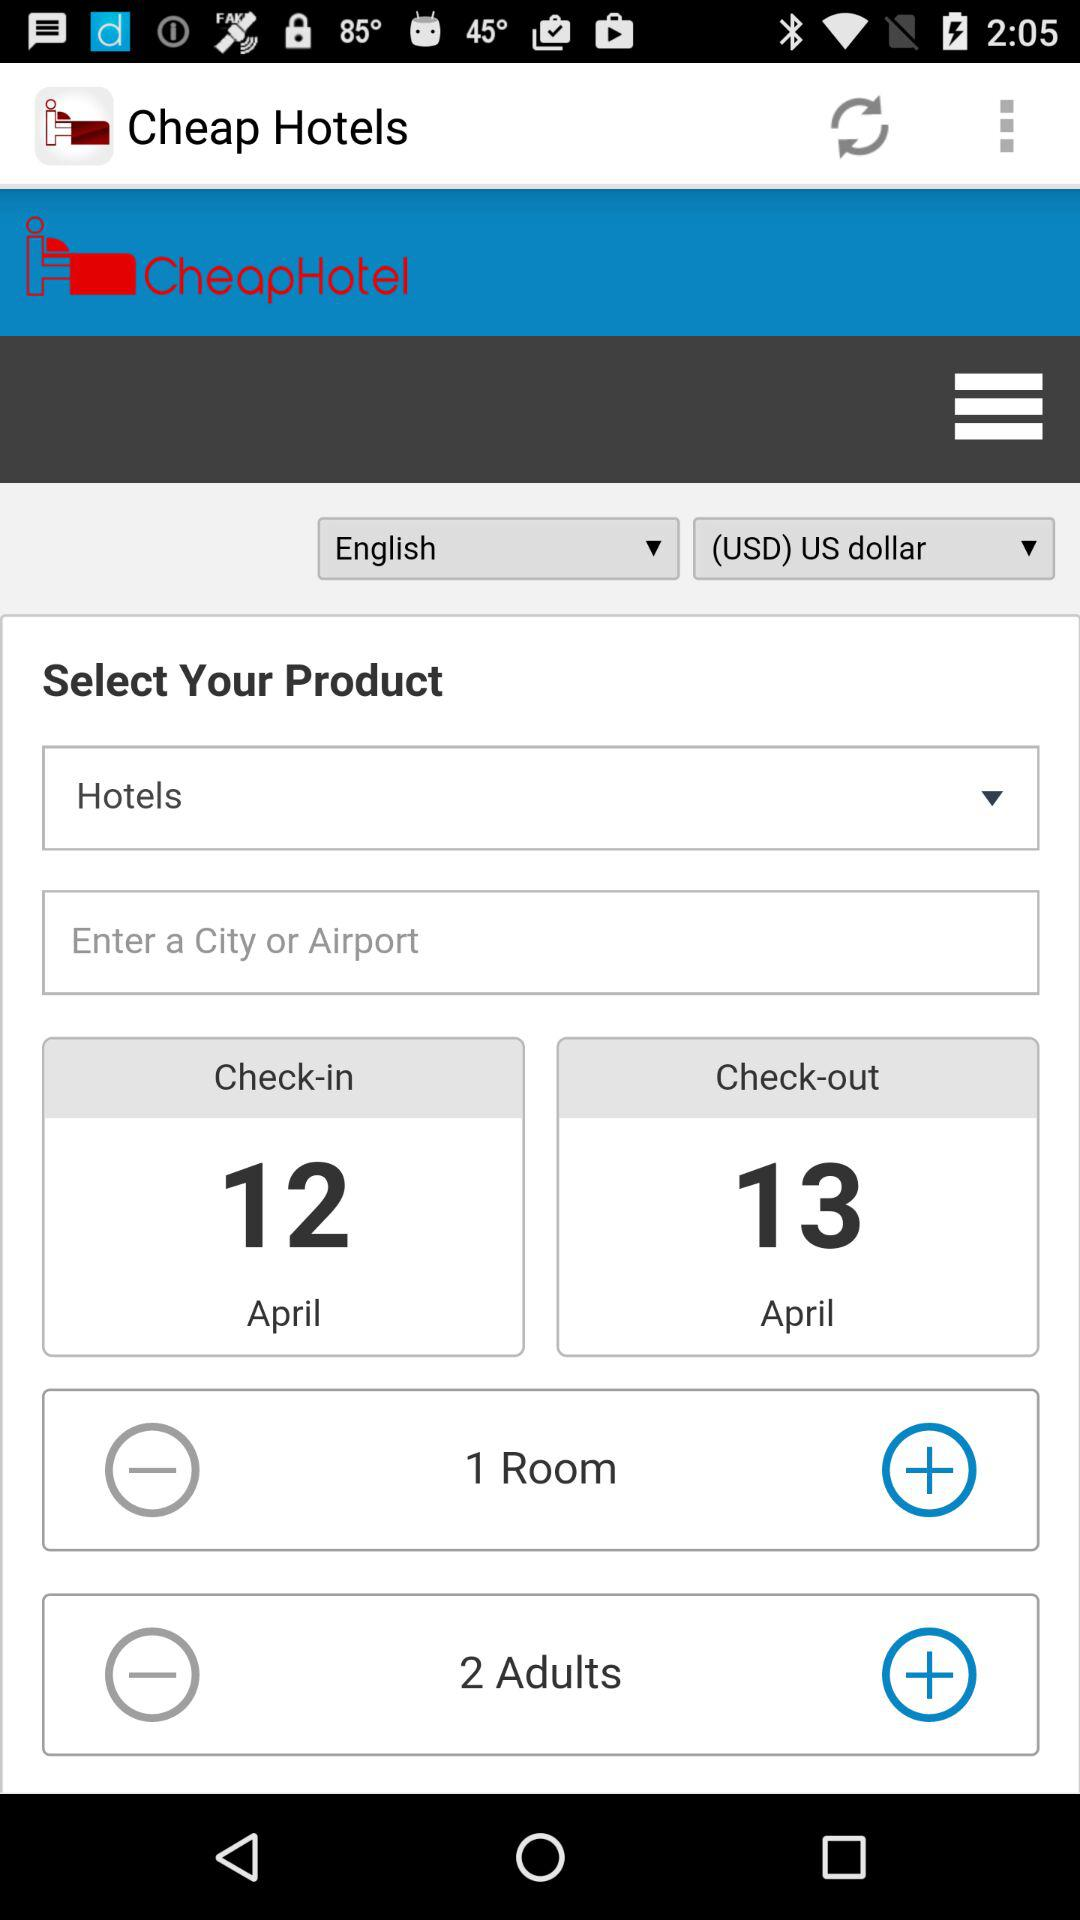Which language is selected? The selected language is "English". 